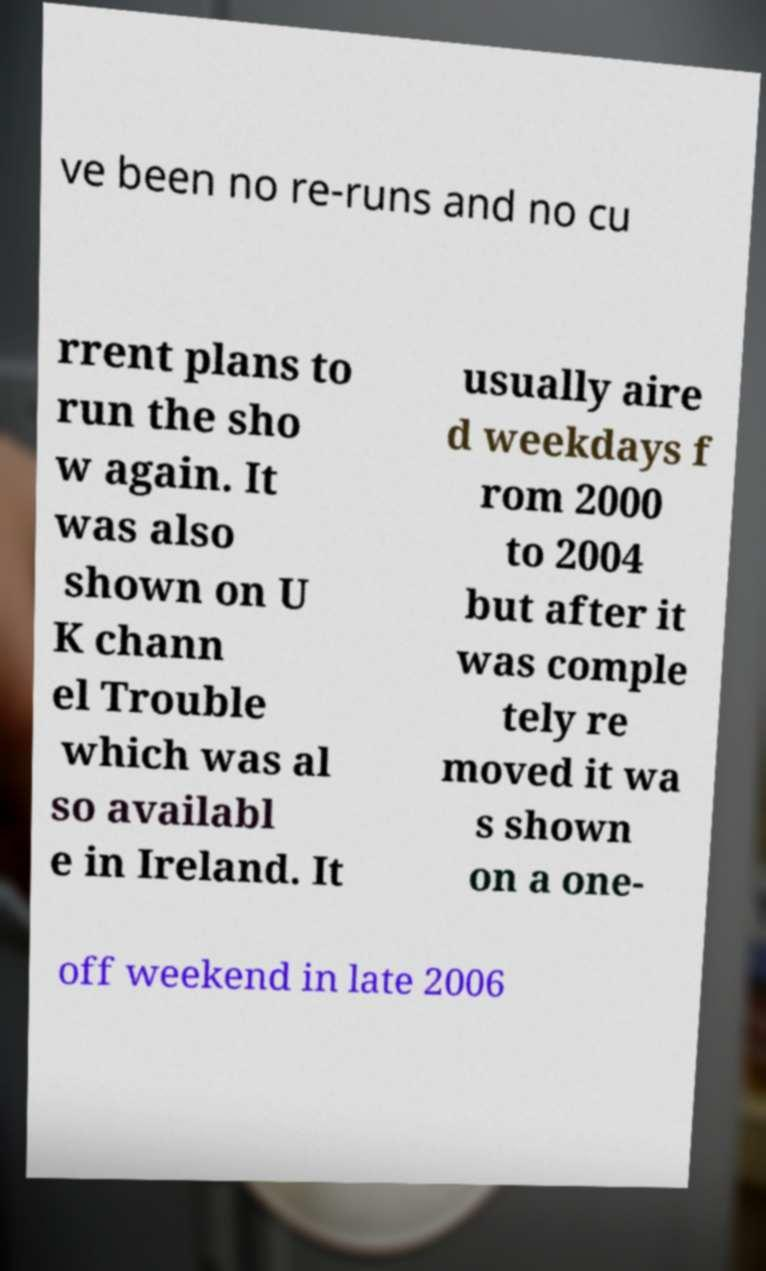Can you read and provide the text displayed in the image?This photo seems to have some interesting text. Can you extract and type it out for me? ve been no re-runs and no cu rrent plans to run the sho w again. It was also shown on U K chann el Trouble which was al so availabl e in Ireland. It usually aire d weekdays f rom 2000 to 2004 but after it was comple tely re moved it wa s shown on a one- off weekend in late 2006 